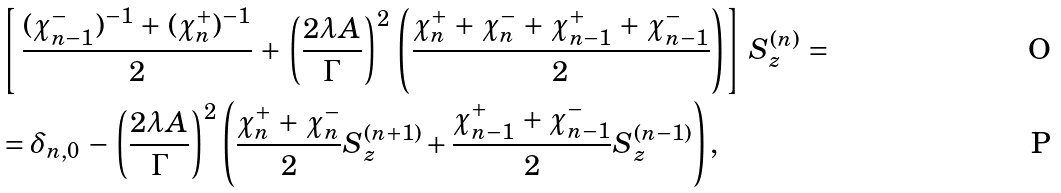Convert formula to latex. <formula><loc_0><loc_0><loc_500><loc_500>& \left [ \, \frac { ( \chi _ { n - 1 } ^ { - } ) ^ { - 1 } \, + \, ( \chi _ { n } ^ { + } ) ^ { - 1 } } { 2 } \, + \, \left ( \frac { 2 \lambda A } { \Gamma } \right ) ^ { 2 } \, \left ( \frac { \chi _ { n } ^ { + } \, + \, \chi _ { n } ^ { - } \, + \, \chi _ { n - 1 } ^ { + } \, + \, \chi _ { n - 1 } ^ { - } } { 2 } \right ) \right ] \, S _ { z } ^ { ( n ) } \, = \\ & = \delta _ { n , 0 } \, - \, \left ( \frac { 2 \lambda A } { \Gamma } \right ) ^ { 2 } \left ( \frac { \chi _ { n } ^ { + } \, + \, \chi _ { n } ^ { - } } { 2 } S _ { z } ^ { ( n + 1 ) } + \frac { \chi _ { n - 1 } ^ { + } \, + \, \chi _ { n - 1 } ^ { - } } { 2 } S _ { z } ^ { ( n - 1 ) } \right ) ,</formula> 